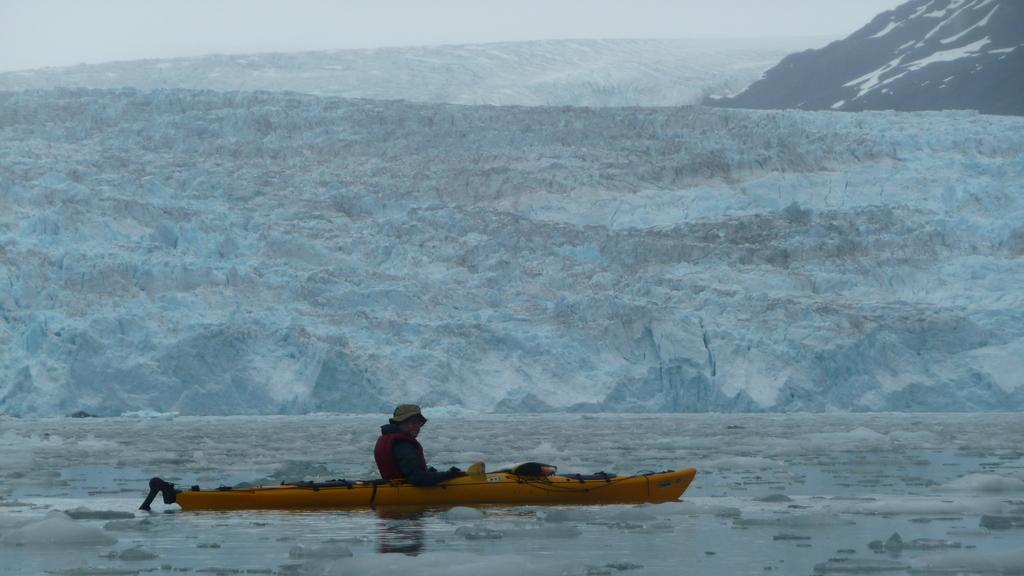Who is present in the image? There is a person in the image. What is the person doing in the image? The person is in a boat. Where is the boat located? The boat is on the water. What can be seen in the background of the image? There are mountains and the sky visible in the background of the image. What type of light is being used by the cook in the image? There is no cook or light present in the image; it features a person in a boat on the water with mountains and the sky visible in the background. 